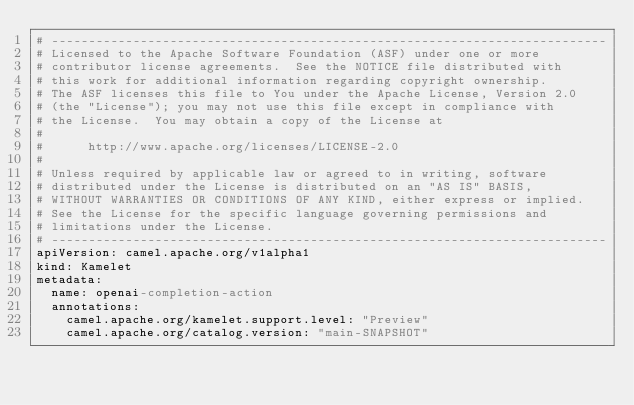Convert code to text. <code><loc_0><loc_0><loc_500><loc_500><_YAML_># ---------------------------------------------------------------------------
# Licensed to the Apache Software Foundation (ASF) under one or more
# contributor license agreements.  See the NOTICE file distributed with
# this work for additional information regarding copyright ownership.
# The ASF licenses this file to You under the Apache License, Version 2.0
# (the "License"); you may not use this file except in compliance with
# the License.  You may obtain a copy of the License at
#
#      http://www.apache.org/licenses/LICENSE-2.0
#
# Unless required by applicable law or agreed to in writing, software
# distributed under the License is distributed on an "AS IS" BASIS,
# WITHOUT WARRANTIES OR CONDITIONS OF ANY KIND, either express or implied.
# See the License for the specific language governing permissions and
# limitations under the License.
# ---------------------------------------------------------------------------
apiVersion: camel.apache.org/v1alpha1
kind: Kamelet
metadata:
  name: openai-completion-action
  annotations:
    camel.apache.org/kamelet.support.level: "Preview"
    camel.apache.org/catalog.version: "main-SNAPSHOT"</code> 